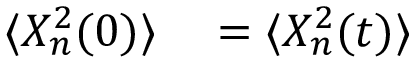<formula> <loc_0><loc_0><loc_500><loc_500>\begin{array} { r l } { \langle X _ { n } ^ { 2 } ( 0 ) \rangle } & = \langle X _ { n } ^ { 2 } ( t ) \rangle } \end{array}</formula> 